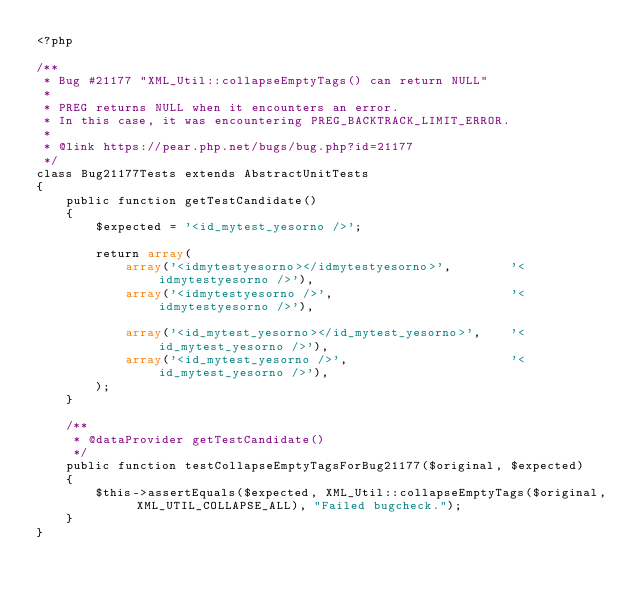Convert code to text. <code><loc_0><loc_0><loc_500><loc_500><_PHP_><?php

/**
 * Bug #21177 "XML_Util::collapseEmptyTags() can return NULL"
 *
 * PREG returns NULL when it encounters an error.
 * In this case, it was encountering PREG_BACKTRACK_LIMIT_ERROR.
 *
 * @link https://pear.php.net/bugs/bug.php?id=21177
 */
class Bug21177Tests extends AbstractUnitTests
{
    public function getTestCandidate()
    {
        $expected = '<id_mytest_yesorno />';

        return array(
            array('<idmytestyesorno></idmytestyesorno>',        '<idmytestyesorno />'),
            array('<idmytestyesorno />',                        '<idmytestyesorno />'),

            array('<id_mytest_yesorno></id_mytest_yesorno>',    '<id_mytest_yesorno />'),
            array('<id_mytest_yesorno />',                      '<id_mytest_yesorno />'),
        );
    }

    /**
     * @dataProvider getTestCandidate()
     */
    public function testCollapseEmptyTagsForBug21177($original, $expected)
    {
        $this->assertEquals($expected, XML_Util::collapseEmptyTags($original, XML_UTIL_COLLAPSE_ALL), "Failed bugcheck.");
    }
}
</code> 